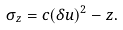Convert formula to latex. <formula><loc_0><loc_0><loc_500><loc_500>\sigma _ { z } = c ( \delta u ) ^ { 2 } - z .</formula> 